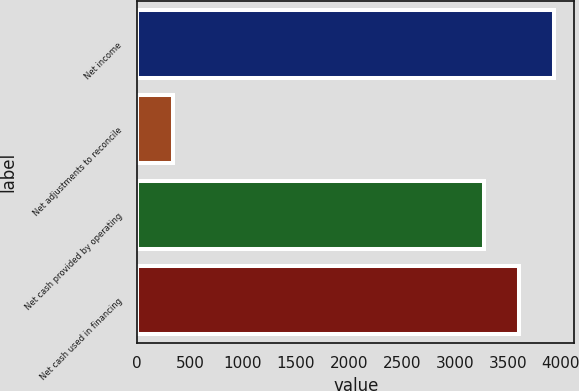<chart> <loc_0><loc_0><loc_500><loc_500><bar_chart><fcel>Net income<fcel>Net adjustments to reconcile<fcel>Net cash provided by operating<fcel>Net cash used in financing<nl><fcel>3932.4<fcel>345<fcel>3277<fcel>3604.7<nl></chart> 